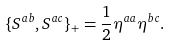<formula> <loc_0><loc_0><loc_500><loc_500>\{ S ^ { a b } , S ^ { a c } \} _ { + } = \frac { 1 } { 2 } \eta ^ { a a } \eta ^ { b c } .</formula> 